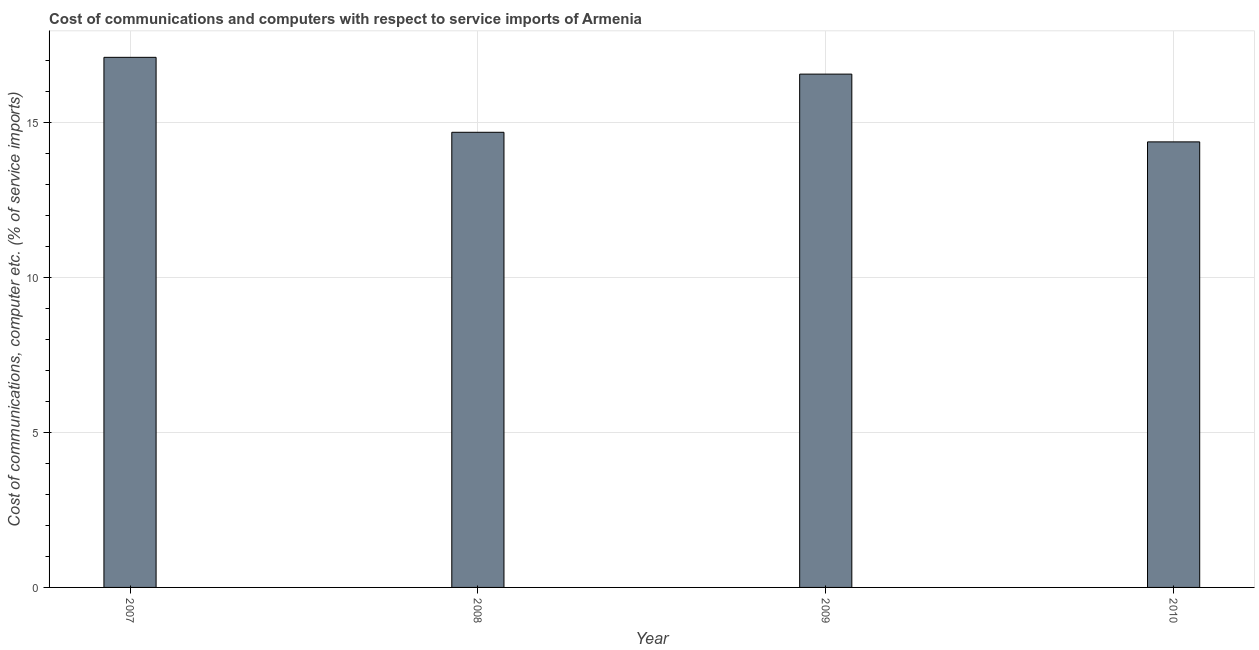Does the graph contain any zero values?
Ensure brevity in your answer.  No. Does the graph contain grids?
Give a very brief answer. Yes. What is the title of the graph?
Offer a terse response. Cost of communications and computers with respect to service imports of Armenia. What is the label or title of the Y-axis?
Provide a succinct answer. Cost of communications, computer etc. (% of service imports). What is the cost of communications and computer in 2009?
Offer a very short reply. 16.57. Across all years, what is the maximum cost of communications and computer?
Your response must be concise. 17.12. Across all years, what is the minimum cost of communications and computer?
Your response must be concise. 14.39. In which year was the cost of communications and computer minimum?
Your answer should be compact. 2010. What is the sum of the cost of communications and computer?
Keep it short and to the point. 62.77. What is the difference between the cost of communications and computer in 2007 and 2009?
Your response must be concise. 0.54. What is the average cost of communications and computer per year?
Offer a terse response. 15.69. What is the median cost of communications and computer?
Provide a succinct answer. 15.64. In how many years, is the cost of communications and computer greater than 8 %?
Provide a short and direct response. 4. Do a majority of the years between 2009 and 2010 (inclusive) have cost of communications and computer greater than 6 %?
Your answer should be very brief. Yes. Is the cost of communications and computer in 2007 less than that in 2008?
Offer a very short reply. No. Is the difference between the cost of communications and computer in 2007 and 2009 greater than the difference between any two years?
Provide a short and direct response. No. What is the difference between the highest and the second highest cost of communications and computer?
Your answer should be compact. 0.54. What is the difference between the highest and the lowest cost of communications and computer?
Keep it short and to the point. 2.73. In how many years, is the cost of communications and computer greater than the average cost of communications and computer taken over all years?
Provide a short and direct response. 2. How many bars are there?
Give a very brief answer. 4. What is the Cost of communications, computer etc. (% of service imports) in 2007?
Your response must be concise. 17.12. What is the Cost of communications, computer etc. (% of service imports) in 2008?
Make the answer very short. 14.7. What is the Cost of communications, computer etc. (% of service imports) of 2009?
Offer a very short reply. 16.57. What is the Cost of communications, computer etc. (% of service imports) of 2010?
Offer a terse response. 14.39. What is the difference between the Cost of communications, computer etc. (% of service imports) in 2007 and 2008?
Provide a succinct answer. 2.42. What is the difference between the Cost of communications, computer etc. (% of service imports) in 2007 and 2009?
Keep it short and to the point. 0.54. What is the difference between the Cost of communications, computer etc. (% of service imports) in 2007 and 2010?
Offer a terse response. 2.73. What is the difference between the Cost of communications, computer etc. (% of service imports) in 2008 and 2009?
Provide a short and direct response. -1.88. What is the difference between the Cost of communications, computer etc. (% of service imports) in 2008 and 2010?
Provide a short and direct response. 0.31. What is the difference between the Cost of communications, computer etc. (% of service imports) in 2009 and 2010?
Make the answer very short. 2.19. What is the ratio of the Cost of communications, computer etc. (% of service imports) in 2007 to that in 2008?
Keep it short and to the point. 1.17. What is the ratio of the Cost of communications, computer etc. (% of service imports) in 2007 to that in 2009?
Provide a short and direct response. 1.03. What is the ratio of the Cost of communications, computer etc. (% of service imports) in 2007 to that in 2010?
Provide a succinct answer. 1.19. What is the ratio of the Cost of communications, computer etc. (% of service imports) in 2008 to that in 2009?
Your answer should be compact. 0.89. What is the ratio of the Cost of communications, computer etc. (% of service imports) in 2009 to that in 2010?
Your response must be concise. 1.15. 